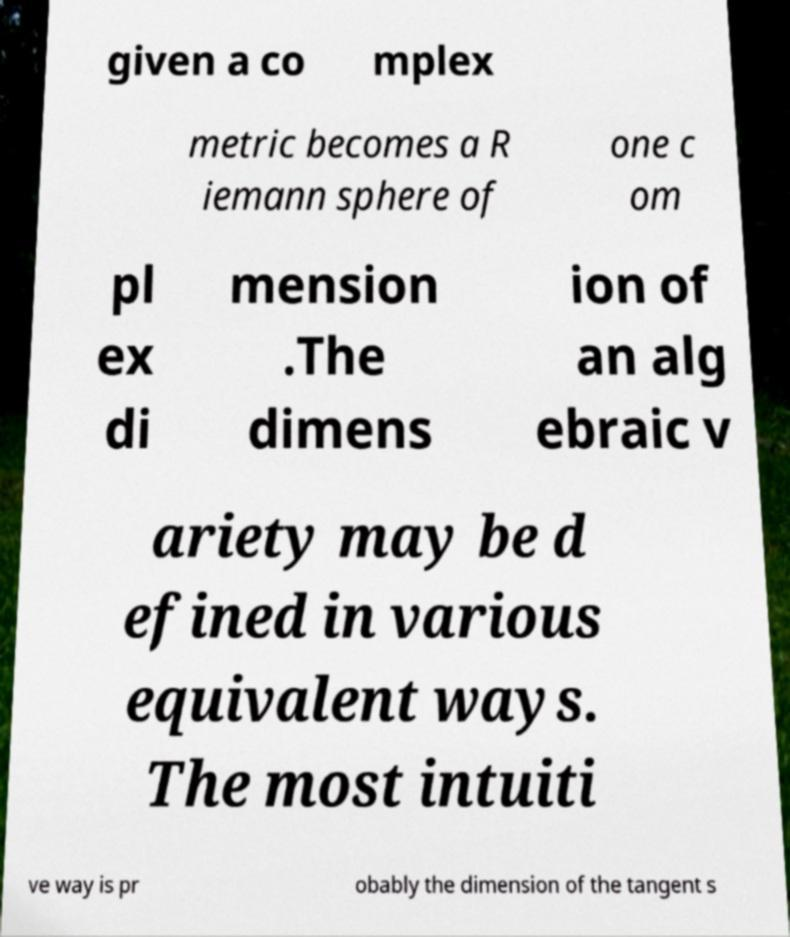Please identify and transcribe the text found in this image. given a co mplex metric becomes a R iemann sphere of one c om pl ex di mension .The dimens ion of an alg ebraic v ariety may be d efined in various equivalent ways. The most intuiti ve way is pr obably the dimension of the tangent s 